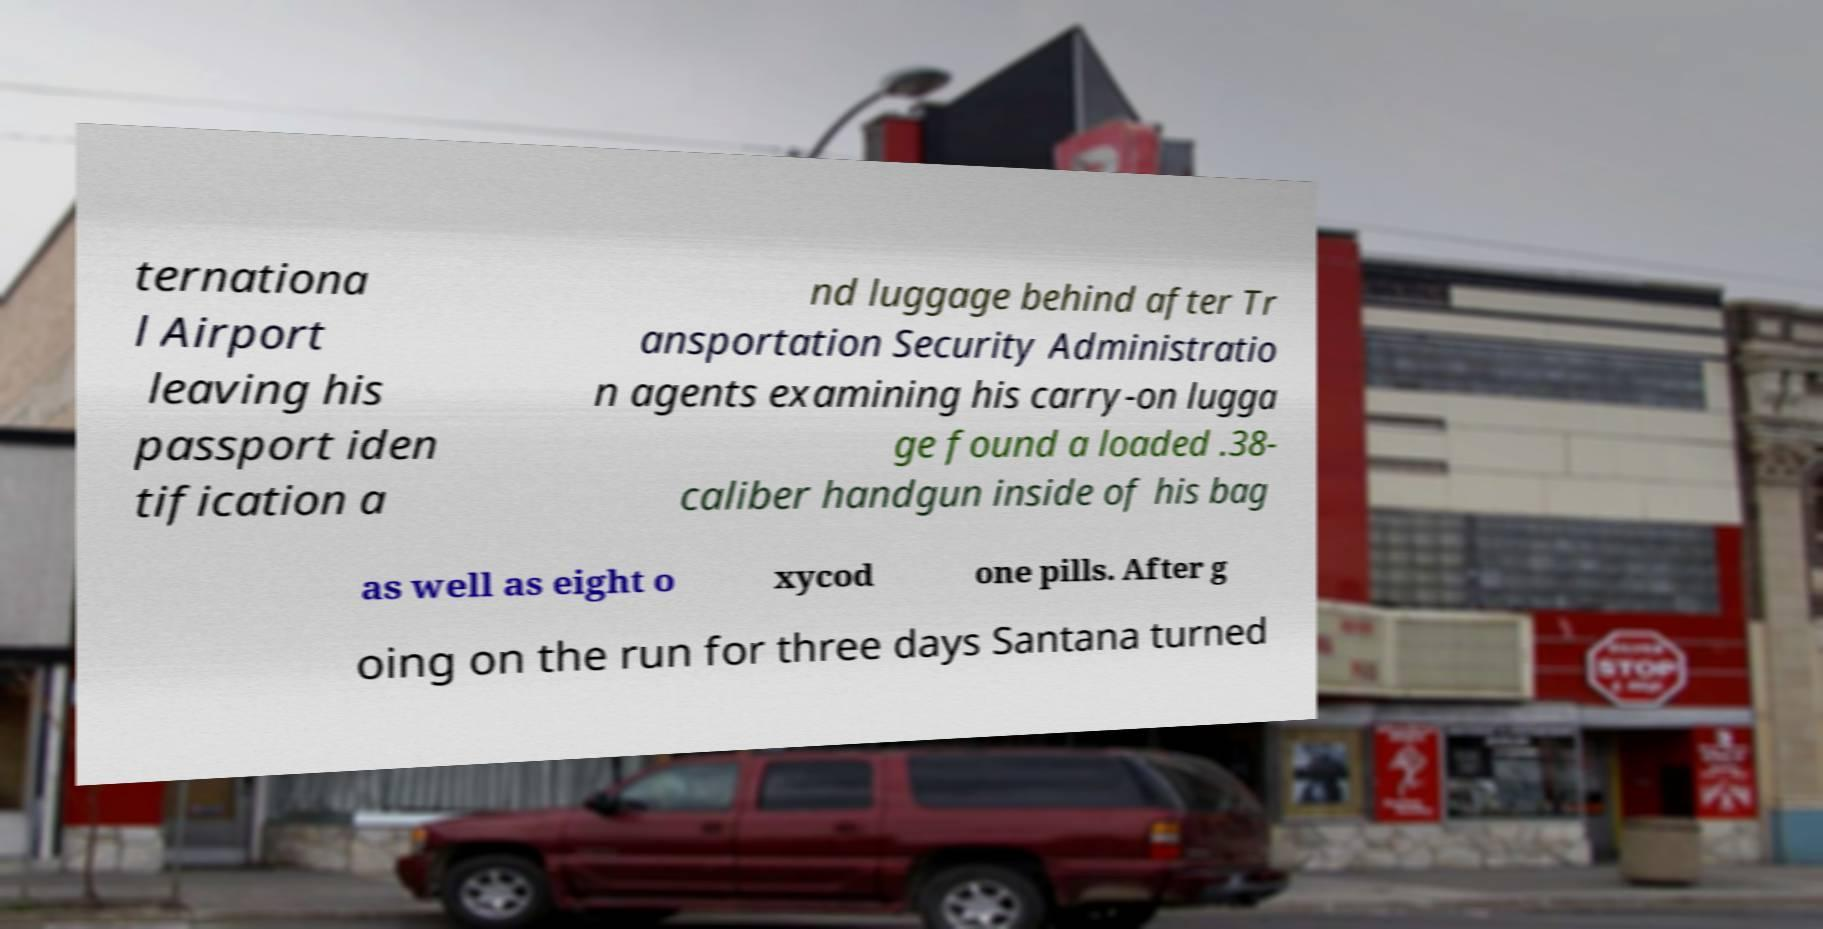Can you read and provide the text displayed in the image?This photo seems to have some interesting text. Can you extract and type it out for me? ternationa l Airport leaving his passport iden tification a nd luggage behind after Tr ansportation Security Administratio n agents examining his carry-on lugga ge found a loaded .38- caliber handgun inside of his bag as well as eight o xycod one pills. After g oing on the run for three days Santana turned 